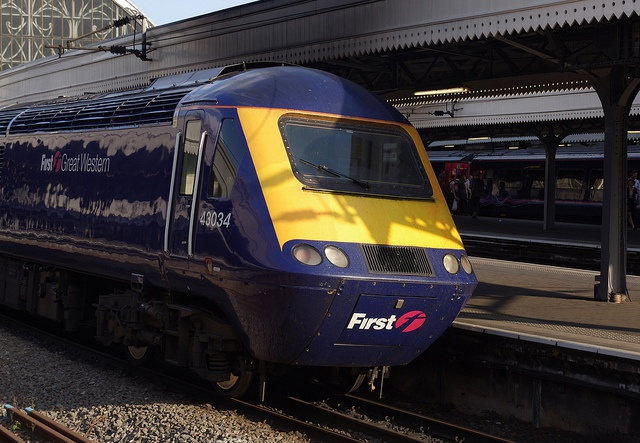Describe the objects in this image and their specific colors. I can see train in gray, black, navy, and gold tones, train in gray, black, and maroon tones, people in black and gray tones, people in gray, black, maroon, and brown tones, and people in gray, black, and maroon tones in this image. 